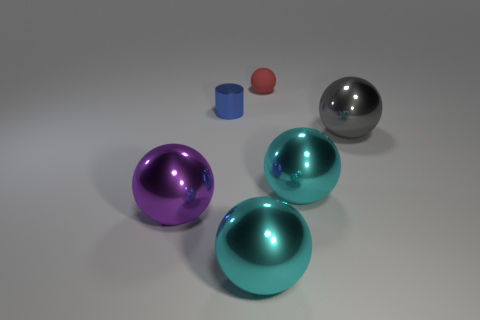There is a red rubber object that is the same shape as the large gray thing; what size is it?
Make the answer very short. Small. There is a big object that is in front of the big purple metallic ball; does it have the same shape as the tiny blue thing?
Give a very brief answer. No. There is a metallic object behind the big gray metal ball; what is its color?
Make the answer very short. Blue. What number of other objects are there of the same size as the rubber ball?
Keep it short and to the point. 1. Is there anything else that is the same shape as the tiny blue metallic thing?
Your response must be concise. No. Are there the same number of red rubber things that are behind the tiny red sphere and large red rubber cylinders?
Give a very brief answer. Yes. How many purple balls are the same material as the cylinder?
Offer a very short reply. 1. The cylinder that is the same material as the purple thing is what color?
Provide a succinct answer. Blue. Do the tiny matte thing and the small metal object have the same shape?
Provide a short and direct response. No. There is a ball that is behind the metallic object that is behind the big gray shiny sphere; is there a large cyan metallic object that is on the left side of it?
Offer a terse response. Yes. 